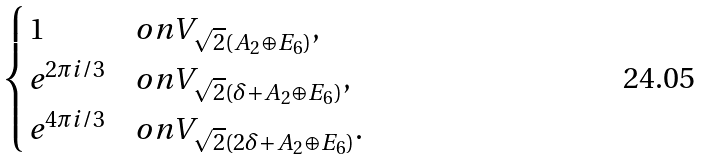<formula> <loc_0><loc_0><loc_500><loc_500>\begin{cases} 1 & o n V _ { \sqrt { 2 } ( A _ { 2 } \oplus E _ { 6 } ) } , \\ e ^ { 2 \pi i / 3 } & o n V _ { \sqrt { 2 } ( \delta + A _ { 2 } \oplus E _ { 6 } ) } , \\ e ^ { 4 \pi i / 3 } & o n V _ { \sqrt { 2 } ( 2 \delta + A _ { 2 } \oplus E _ { 6 } ) } . \end{cases}</formula> 